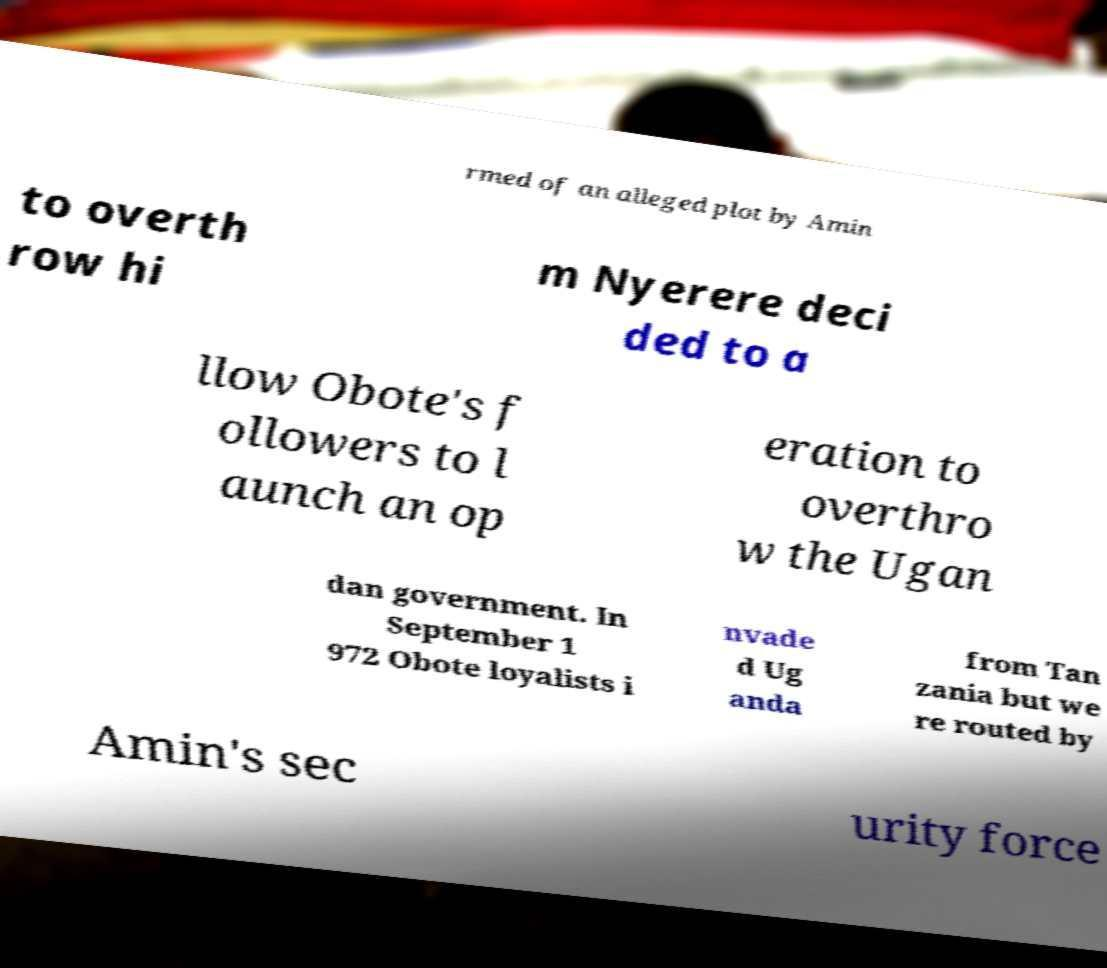Can you accurately transcribe the text from the provided image for me? rmed of an alleged plot by Amin to overth row hi m Nyerere deci ded to a llow Obote's f ollowers to l aunch an op eration to overthro w the Ugan dan government. In September 1 972 Obote loyalists i nvade d Ug anda from Tan zania but we re routed by Amin's sec urity force 